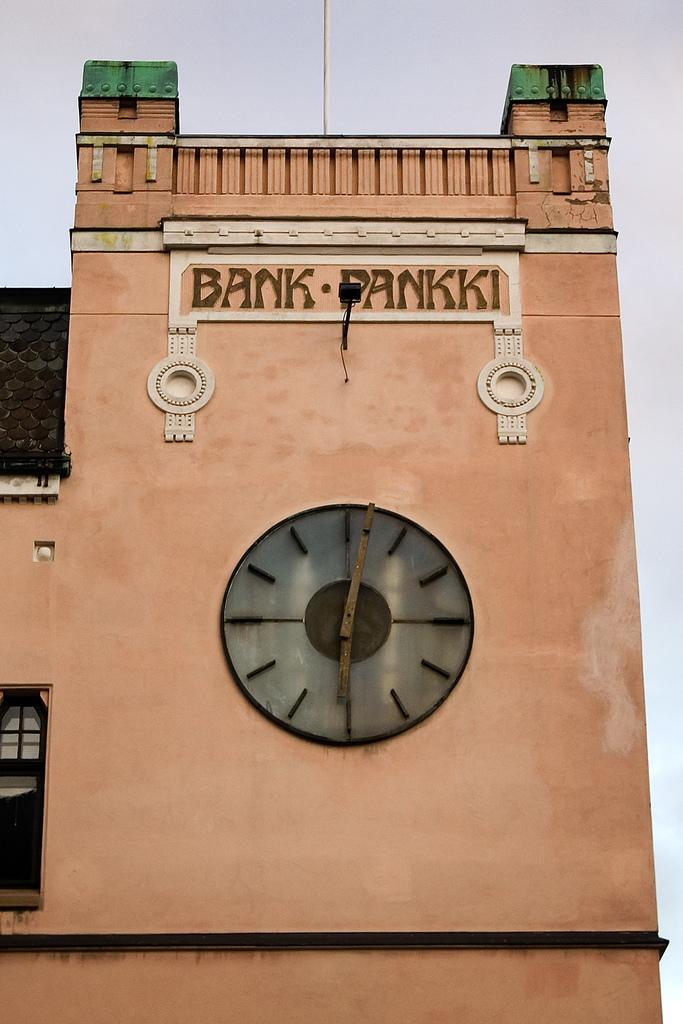<image>
Share a concise interpretation of the image provided. A building says Bank Pankki above a simple clock on the wall. 